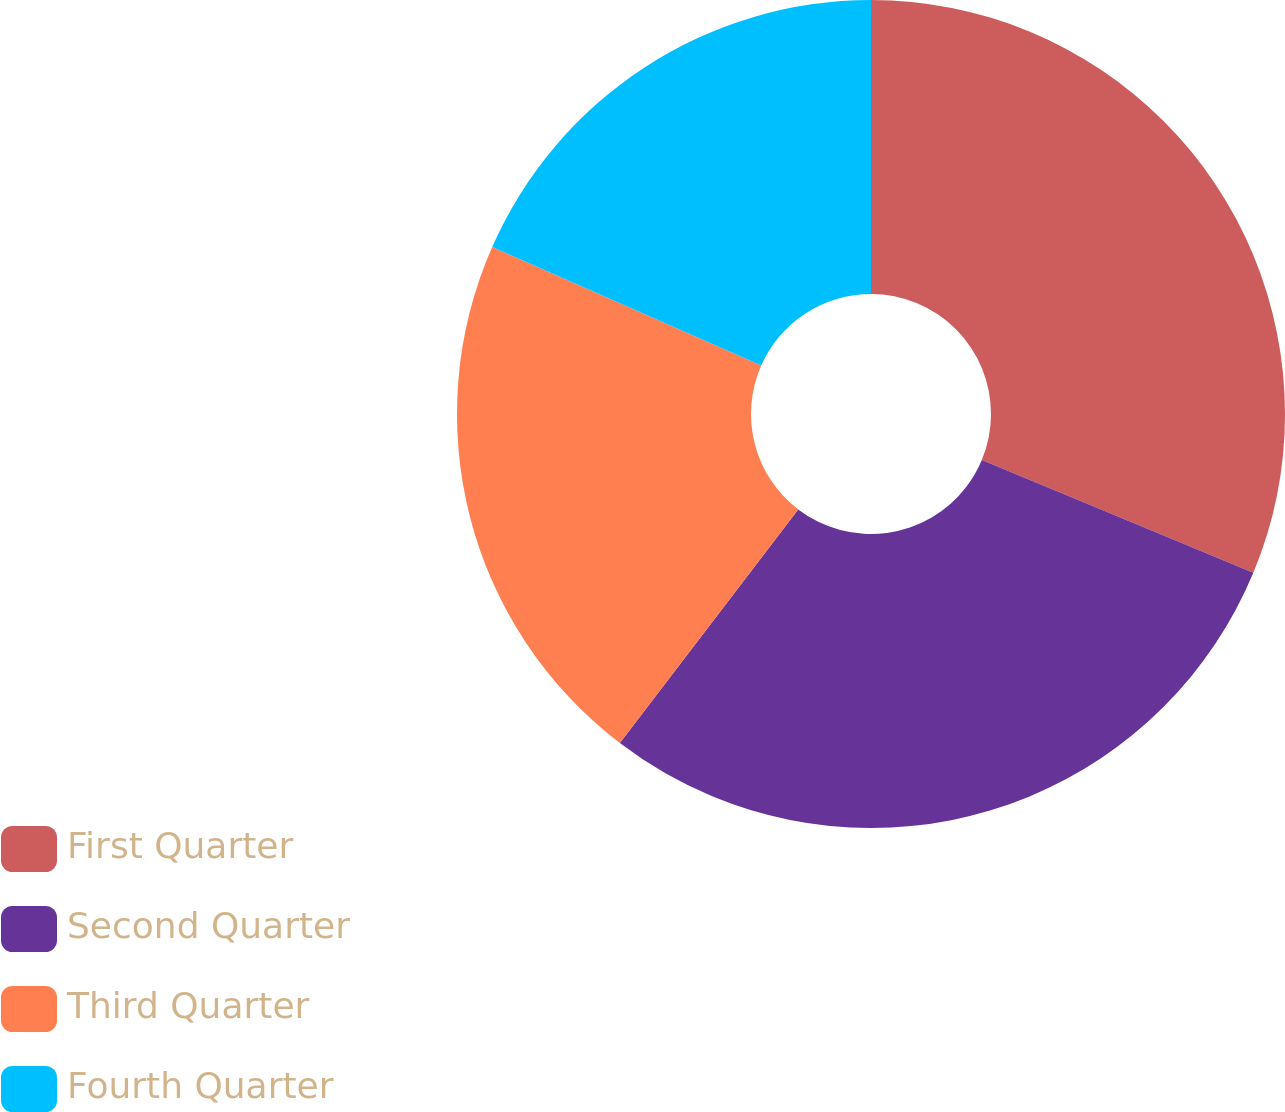<chart> <loc_0><loc_0><loc_500><loc_500><pie_chart><fcel>First Quarter<fcel>Second Quarter<fcel>Third Quarter<fcel>Fourth Quarter<nl><fcel>31.27%<fcel>29.11%<fcel>21.24%<fcel>18.39%<nl></chart> 